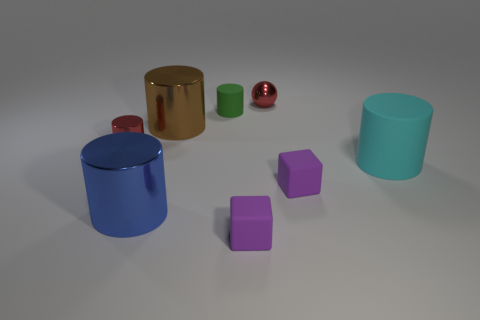How many purple blocks must be subtracted to get 1 purple blocks? 1 Subtract 3 cylinders. How many cylinders are left? 2 Subtract all green cylinders. How many cylinders are left? 4 Subtract all small metallic cylinders. How many cylinders are left? 4 Add 1 tiny purple objects. How many objects exist? 9 Subtract all brown cylinders. Subtract all brown cubes. How many cylinders are left? 4 Subtract all cubes. How many objects are left? 6 Add 1 red spheres. How many red spheres are left? 2 Add 5 red cylinders. How many red cylinders exist? 6 Subtract 0 purple spheres. How many objects are left? 8 